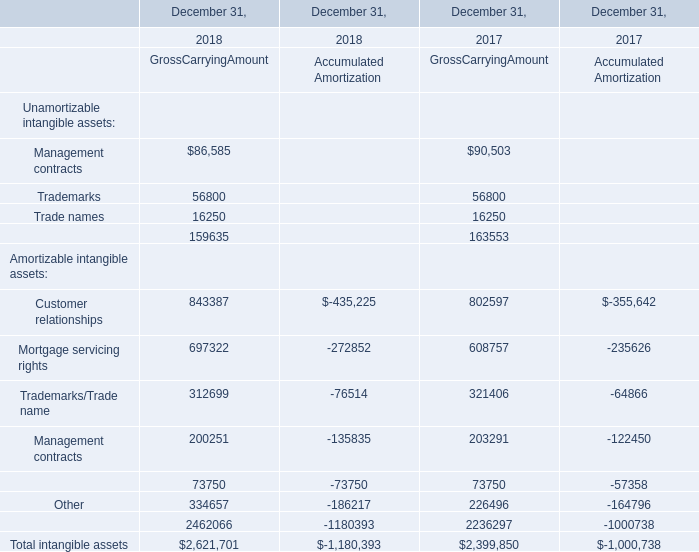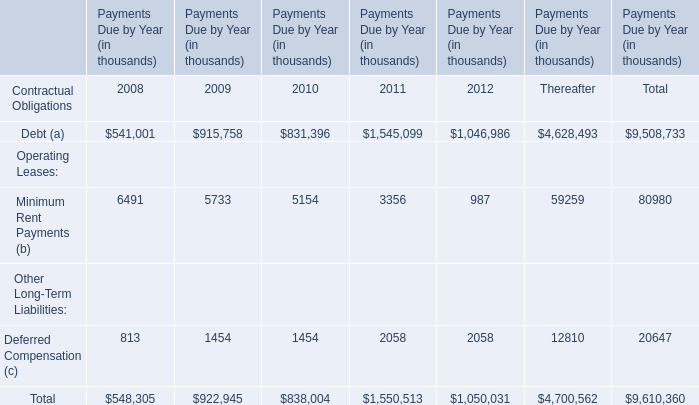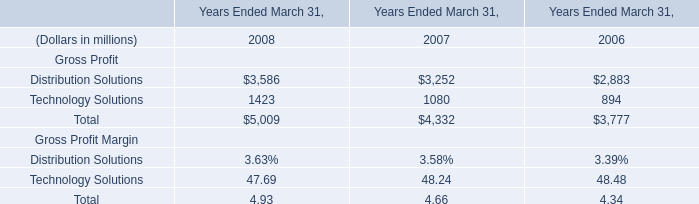What is the sum of Customer relationships of GrossCarryingAmount in 2018 and Debt (a) of Contractual Obligations in 2009? (in thousand) 
Computations: (843387 + 915758)
Answer: 1759145.0. 